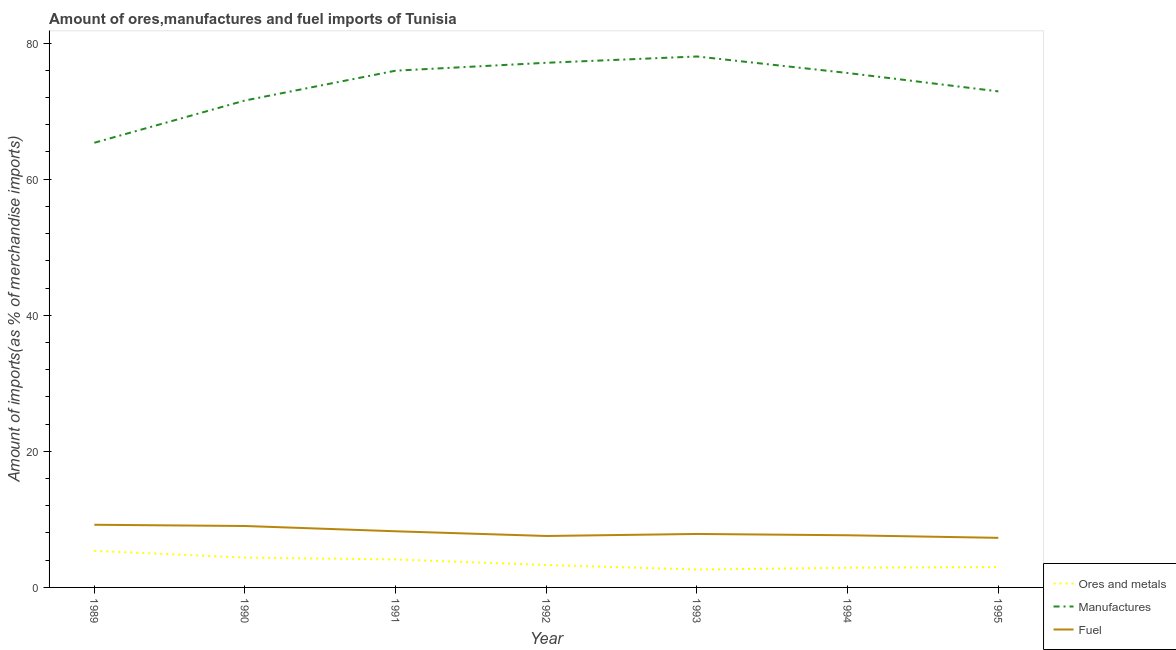How many different coloured lines are there?
Offer a very short reply. 3. Does the line corresponding to percentage of manufactures imports intersect with the line corresponding to percentage of ores and metals imports?
Your response must be concise. No. What is the percentage of ores and metals imports in 1995?
Your answer should be very brief. 2.99. Across all years, what is the maximum percentage of manufactures imports?
Give a very brief answer. 78.03. Across all years, what is the minimum percentage of ores and metals imports?
Keep it short and to the point. 2.63. What is the total percentage of ores and metals imports in the graph?
Offer a terse response. 25.68. What is the difference between the percentage of ores and metals imports in 1989 and that in 1992?
Keep it short and to the point. 2.09. What is the difference between the percentage of manufactures imports in 1995 and the percentage of ores and metals imports in 1991?
Keep it short and to the point. 68.79. What is the average percentage of manufactures imports per year?
Offer a terse response. 73.78. In the year 1989, what is the difference between the percentage of manufactures imports and percentage of ores and metals imports?
Make the answer very short. 59.97. In how many years, is the percentage of manufactures imports greater than 44 %?
Offer a terse response. 7. What is the ratio of the percentage of ores and metals imports in 1993 to that in 1994?
Provide a short and direct response. 0.91. Is the difference between the percentage of fuel imports in 1992 and 1994 greater than the difference between the percentage of ores and metals imports in 1992 and 1994?
Provide a succinct answer. No. What is the difference between the highest and the second highest percentage of manufactures imports?
Your answer should be compact. 0.93. What is the difference between the highest and the lowest percentage of manufactures imports?
Offer a terse response. 12.68. In how many years, is the percentage of fuel imports greater than the average percentage of fuel imports taken over all years?
Ensure brevity in your answer.  3. How many lines are there?
Give a very brief answer. 3. What is the difference between two consecutive major ticks on the Y-axis?
Your response must be concise. 20. Where does the legend appear in the graph?
Keep it short and to the point. Bottom right. How many legend labels are there?
Give a very brief answer. 3. How are the legend labels stacked?
Provide a succinct answer. Vertical. What is the title of the graph?
Provide a succinct answer. Amount of ores,manufactures and fuel imports of Tunisia. Does "Refusal of sex" appear as one of the legend labels in the graph?
Your response must be concise. No. What is the label or title of the X-axis?
Ensure brevity in your answer.  Year. What is the label or title of the Y-axis?
Your response must be concise. Amount of imports(as % of merchandise imports). What is the Amount of imports(as % of merchandise imports) in Ores and metals in 1989?
Offer a very short reply. 5.38. What is the Amount of imports(as % of merchandise imports) in Manufactures in 1989?
Give a very brief answer. 65.35. What is the Amount of imports(as % of merchandise imports) in Fuel in 1989?
Make the answer very short. 9.21. What is the Amount of imports(as % of merchandise imports) in Ores and metals in 1990?
Offer a terse response. 4.38. What is the Amount of imports(as % of merchandise imports) of Manufactures in 1990?
Make the answer very short. 71.56. What is the Amount of imports(as % of merchandise imports) of Fuel in 1990?
Provide a succinct answer. 9.03. What is the Amount of imports(as % of merchandise imports) in Ores and metals in 1991?
Give a very brief answer. 4.11. What is the Amount of imports(as % of merchandise imports) in Manufactures in 1991?
Your answer should be compact. 75.94. What is the Amount of imports(as % of merchandise imports) of Fuel in 1991?
Your answer should be compact. 8.25. What is the Amount of imports(as % of merchandise imports) in Ores and metals in 1992?
Offer a very short reply. 3.3. What is the Amount of imports(as % of merchandise imports) in Manufactures in 1992?
Your answer should be compact. 77.1. What is the Amount of imports(as % of merchandise imports) in Fuel in 1992?
Provide a short and direct response. 7.56. What is the Amount of imports(as % of merchandise imports) in Ores and metals in 1993?
Offer a terse response. 2.63. What is the Amount of imports(as % of merchandise imports) of Manufactures in 1993?
Give a very brief answer. 78.03. What is the Amount of imports(as % of merchandise imports) of Fuel in 1993?
Provide a succinct answer. 7.86. What is the Amount of imports(as % of merchandise imports) in Ores and metals in 1994?
Offer a very short reply. 2.89. What is the Amount of imports(as % of merchandise imports) of Manufactures in 1994?
Provide a succinct answer. 75.6. What is the Amount of imports(as % of merchandise imports) of Fuel in 1994?
Your answer should be very brief. 7.67. What is the Amount of imports(as % of merchandise imports) in Ores and metals in 1995?
Your response must be concise. 2.99. What is the Amount of imports(as % of merchandise imports) of Manufactures in 1995?
Your answer should be compact. 72.9. What is the Amount of imports(as % of merchandise imports) in Fuel in 1995?
Provide a succinct answer. 7.29. Across all years, what is the maximum Amount of imports(as % of merchandise imports) in Ores and metals?
Give a very brief answer. 5.38. Across all years, what is the maximum Amount of imports(as % of merchandise imports) in Manufactures?
Make the answer very short. 78.03. Across all years, what is the maximum Amount of imports(as % of merchandise imports) of Fuel?
Ensure brevity in your answer.  9.21. Across all years, what is the minimum Amount of imports(as % of merchandise imports) of Ores and metals?
Provide a succinct answer. 2.63. Across all years, what is the minimum Amount of imports(as % of merchandise imports) of Manufactures?
Your answer should be compact. 65.35. Across all years, what is the minimum Amount of imports(as % of merchandise imports) of Fuel?
Offer a very short reply. 7.29. What is the total Amount of imports(as % of merchandise imports) in Ores and metals in the graph?
Ensure brevity in your answer.  25.68. What is the total Amount of imports(as % of merchandise imports) of Manufactures in the graph?
Give a very brief answer. 516.47. What is the total Amount of imports(as % of merchandise imports) of Fuel in the graph?
Give a very brief answer. 56.86. What is the difference between the Amount of imports(as % of merchandise imports) of Manufactures in 1989 and that in 1990?
Your answer should be compact. -6.21. What is the difference between the Amount of imports(as % of merchandise imports) in Fuel in 1989 and that in 1990?
Offer a terse response. 0.18. What is the difference between the Amount of imports(as % of merchandise imports) in Ores and metals in 1989 and that in 1991?
Ensure brevity in your answer.  1.27. What is the difference between the Amount of imports(as % of merchandise imports) in Manufactures in 1989 and that in 1991?
Keep it short and to the point. -10.59. What is the difference between the Amount of imports(as % of merchandise imports) in Fuel in 1989 and that in 1991?
Provide a succinct answer. 0.96. What is the difference between the Amount of imports(as % of merchandise imports) in Ores and metals in 1989 and that in 1992?
Your answer should be very brief. 2.09. What is the difference between the Amount of imports(as % of merchandise imports) in Manufactures in 1989 and that in 1992?
Offer a terse response. -11.75. What is the difference between the Amount of imports(as % of merchandise imports) in Fuel in 1989 and that in 1992?
Make the answer very short. 1.65. What is the difference between the Amount of imports(as % of merchandise imports) of Ores and metals in 1989 and that in 1993?
Your answer should be very brief. 2.75. What is the difference between the Amount of imports(as % of merchandise imports) of Manufactures in 1989 and that in 1993?
Ensure brevity in your answer.  -12.68. What is the difference between the Amount of imports(as % of merchandise imports) in Fuel in 1989 and that in 1993?
Your answer should be compact. 1.35. What is the difference between the Amount of imports(as % of merchandise imports) in Ores and metals in 1989 and that in 1994?
Ensure brevity in your answer.  2.49. What is the difference between the Amount of imports(as % of merchandise imports) in Manufactures in 1989 and that in 1994?
Give a very brief answer. -10.25. What is the difference between the Amount of imports(as % of merchandise imports) of Fuel in 1989 and that in 1994?
Your response must be concise. 1.54. What is the difference between the Amount of imports(as % of merchandise imports) of Ores and metals in 1989 and that in 1995?
Your answer should be compact. 2.39. What is the difference between the Amount of imports(as % of merchandise imports) of Manufactures in 1989 and that in 1995?
Keep it short and to the point. -7.55. What is the difference between the Amount of imports(as % of merchandise imports) of Fuel in 1989 and that in 1995?
Your response must be concise. 1.92. What is the difference between the Amount of imports(as % of merchandise imports) in Ores and metals in 1990 and that in 1991?
Offer a terse response. 0.27. What is the difference between the Amount of imports(as % of merchandise imports) in Manufactures in 1990 and that in 1991?
Provide a short and direct response. -4.38. What is the difference between the Amount of imports(as % of merchandise imports) in Fuel in 1990 and that in 1991?
Your response must be concise. 0.78. What is the difference between the Amount of imports(as % of merchandise imports) of Ores and metals in 1990 and that in 1992?
Your answer should be compact. 1.09. What is the difference between the Amount of imports(as % of merchandise imports) in Manufactures in 1990 and that in 1992?
Ensure brevity in your answer.  -5.54. What is the difference between the Amount of imports(as % of merchandise imports) in Fuel in 1990 and that in 1992?
Ensure brevity in your answer.  1.47. What is the difference between the Amount of imports(as % of merchandise imports) of Ores and metals in 1990 and that in 1993?
Your answer should be very brief. 1.75. What is the difference between the Amount of imports(as % of merchandise imports) of Manufactures in 1990 and that in 1993?
Your response must be concise. -6.47. What is the difference between the Amount of imports(as % of merchandise imports) in Fuel in 1990 and that in 1993?
Offer a terse response. 1.17. What is the difference between the Amount of imports(as % of merchandise imports) of Ores and metals in 1990 and that in 1994?
Your answer should be very brief. 1.49. What is the difference between the Amount of imports(as % of merchandise imports) of Manufactures in 1990 and that in 1994?
Give a very brief answer. -4.04. What is the difference between the Amount of imports(as % of merchandise imports) in Fuel in 1990 and that in 1994?
Make the answer very short. 1.36. What is the difference between the Amount of imports(as % of merchandise imports) of Ores and metals in 1990 and that in 1995?
Make the answer very short. 1.39. What is the difference between the Amount of imports(as % of merchandise imports) of Manufactures in 1990 and that in 1995?
Your response must be concise. -1.34. What is the difference between the Amount of imports(as % of merchandise imports) in Fuel in 1990 and that in 1995?
Keep it short and to the point. 1.74. What is the difference between the Amount of imports(as % of merchandise imports) of Ores and metals in 1991 and that in 1992?
Provide a short and direct response. 0.82. What is the difference between the Amount of imports(as % of merchandise imports) of Manufactures in 1991 and that in 1992?
Provide a short and direct response. -1.16. What is the difference between the Amount of imports(as % of merchandise imports) of Fuel in 1991 and that in 1992?
Offer a terse response. 0.69. What is the difference between the Amount of imports(as % of merchandise imports) of Ores and metals in 1991 and that in 1993?
Make the answer very short. 1.48. What is the difference between the Amount of imports(as % of merchandise imports) of Manufactures in 1991 and that in 1993?
Ensure brevity in your answer.  -2.09. What is the difference between the Amount of imports(as % of merchandise imports) in Fuel in 1991 and that in 1993?
Your answer should be very brief. 0.39. What is the difference between the Amount of imports(as % of merchandise imports) in Ores and metals in 1991 and that in 1994?
Provide a succinct answer. 1.22. What is the difference between the Amount of imports(as % of merchandise imports) in Manufactures in 1991 and that in 1994?
Your answer should be compact. 0.34. What is the difference between the Amount of imports(as % of merchandise imports) of Fuel in 1991 and that in 1994?
Make the answer very short. 0.58. What is the difference between the Amount of imports(as % of merchandise imports) of Ores and metals in 1991 and that in 1995?
Make the answer very short. 1.12. What is the difference between the Amount of imports(as % of merchandise imports) of Manufactures in 1991 and that in 1995?
Give a very brief answer. 3.04. What is the difference between the Amount of imports(as % of merchandise imports) in Fuel in 1991 and that in 1995?
Ensure brevity in your answer.  0.96. What is the difference between the Amount of imports(as % of merchandise imports) in Ores and metals in 1992 and that in 1993?
Your response must be concise. 0.66. What is the difference between the Amount of imports(as % of merchandise imports) of Manufactures in 1992 and that in 1993?
Keep it short and to the point. -0.93. What is the difference between the Amount of imports(as % of merchandise imports) of Fuel in 1992 and that in 1993?
Ensure brevity in your answer.  -0.3. What is the difference between the Amount of imports(as % of merchandise imports) in Ores and metals in 1992 and that in 1994?
Ensure brevity in your answer.  0.41. What is the difference between the Amount of imports(as % of merchandise imports) of Manufactures in 1992 and that in 1994?
Offer a very short reply. 1.5. What is the difference between the Amount of imports(as % of merchandise imports) in Fuel in 1992 and that in 1994?
Make the answer very short. -0.11. What is the difference between the Amount of imports(as % of merchandise imports) in Ores and metals in 1992 and that in 1995?
Ensure brevity in your answer.  0.3. What is the difference between the Amount of imports(as % of merchandise imports) in Manufactures in 1992 and that in 1995?
Give a very brief answer. 4.2. What is the difference between the Amount of imports(as % of merchandise imports) of Fuel in 1992 and that in 1995?
Offer a terse response. 0.27. What is the difference between the Amount of imports(as % of merchandise imports) in Ores and metals in 1993 and that in 1994?
Your answer should be very brief. -0.26. What is the difference between the Amount of imports(as % of merchandise imports) of Manufactures in 1993 and that in 1994?
Provide a succinct answer. 2.43. What is the difference between the Amount of imports(as % of merchandise imports) in Fuel in 1993 and that in 1994?
Ensure brevity in your answer.  0.19. What is the difference between the Amount of imports(as % of merchandise imports) of Ores and metals in 1993 and that in 1995?
Your answer should be very brief. -0.36. What is the difference between the Amount of imports(as % of merchandise imports) in Manufactures in 1993 and that in 1995?
Keep it short and to the point. 5.13. What is the difference between the Amount of imports(as % of merchandise imports) of Fuel in 1993 and that in 1995?
Offer a very short reply. 0.57. What is the difference between the Amount of imports(as % of merchandise imports) in Ores and metals in 1994 and that in 1995?
Make the answer very short. -0.11. What is the difference between the Amount of imports(as % of merchandise imports) in Manufactures in 1994 and that in 1995?
Give a very brief answer. 2.7. What is the difference between the Amount of imports(as % of merchandise imports) in Fuel in 1994 and that in 1995?
Make the answer very short. 0.38. What is the difference between the Amount of imports(as % of merchandise imports) of Ores and metals in 1989 and the Amount of imports(as % of merchandise imports) of Manufactures in 1990?
Offer a very short reply. -66.18. What is the difference between the Amount of imports(as % of merchandise imports) in Ores and metals in 1989 and the Amount of imports(as % of merchandise imports) in Fuel in 1990?
Provide a succinct answer. -3.65. What is the difference between the Amount of imports(as % of merchandise imports) of Manufactures in 1989 and the Amount of imports(as % of merchandise imports) of Fuel in 1990?
Your response must be concise. 56.32. What is the difference between the Amount of imports(as % of merchandise imports) of Ores and metals in 1989 and the Amount of imports(as % of merchandise imports) of Manufactures in 1991?
Make the answer very short. -70.56. What is the difference between the Amount of imports(as % of merchandise imports) in Ores and metals in 1989 and the Amount of imports(as % of merchandise imports) in Fuel in 1991?
Your response must be concise. -2.87. What is the difference between the Amount of imports(as % of merchandise imports) of Manufactures in 1989 and the Amount of imports(as % of merchandise imports) of Fuel in 1991?
Offer a very short reply. 57.1. What is the difference between the Amount of imports(as % of merchandise imports) of Ores and metals in 1989 and the Amount of imports(as % of merchandise imports) of Manufactures in 1992?
Offer a very short reply. -71.72. What is the difference between the Amount of imports(as % of merchandise imports) of Ores and metals in 1989 and the Amount of imports(as % of merchandise imports) of Fuel in 1992?
Ensure brevity in your answer.  -2.18. What is the difference between the Amount of imports(as % of merchandise imports) of Manufactures in 1989 and the Amount of imports(as % of merchandise imports) of Fuel in 1992?
Make the answer very short. 57.79. What is the difference between the Amount of imports(as % of merchandise imports) in Ores and metals in 1989 and the Amount of imports(as % of merchandise imports) in Manufactures in 1993?
Offer a very short reply. -72.65. What is the difference between the Amount of imports(as % of merchandise imports) in Ores and metals in 1989 and the Amount of imports(as % of merchandise imports) in Fuel in 1993?
Provide a short and direct response. -2.48. What is the difference between the Amount of imports(as % of merchandise imports) in Manufactures in 1989 and the Amount of imports(as % of merchandise imports) in Fuel in 1993?
Your answer should be compact. 57.49. What is the difference between the Amount of imports(as % of merchandise imports) in Ores and metals in 1989 and the Amount of imports(as % of merchandise imports) in Manufactures in 1994?
Provide a short and direct response. -70.22. What is the difference between the Amount of imports(as % of merchandise imports) of Ores and metals in 1989 and the Amount of imports(as % of merchandise imports) of Fuel in 1994?
Your response must be concise. -2.29. What is the difference between the Amount of imports(as % of merchandise imports) in Manufactures in 1989 and the Amount of imports(as % of merchandise imports) in Fuel in 1994?
Offer a very short reply. 57.68. What is the difference between the Amount of imports(as % of merchandise imports) of Ores and metals in 1989 and the Amount of imports(as % of merchandise imports) of Manufactures in 1995?
Offer a very short reply. -67.52. What is the difference between the Amount of imports(as % of merchandise imports) of Ores and metals in 1989 and the Amount of imports(as % of merchandise imports) of Fuel in 1995?
Provide a short and direct response. -1.91. What is the difference between the Amount of imports(as % of merchandise imports) of Manufactures in 1989 and the Amount of imports(as % of merchandise imports) of Fuel in 1995?
Your response must be concise. 58.06. What is the difference between the Amount of imports(as % of merchandise imports) in Ores and metals in 1990 and the Amount of imports(as % of merchandise imports) in Manufactures in 1991?
Your response must be concise. -71.56. What is the difference between the Amount of imports(as % of merchandise imports) of Ores and metals in 1990 and the Amount of imports(as % of merchandise imports) of Fuel in 1991?
Give a very brief answer. -3.87. What is the difference between the Amount of imports(as % of merchandise imports) of Manufactures in 1990 and the Amount of imports(as % of merchandise imports) of Fuel in 1991?
Your answer should be compact. 63.31. What is the difference between the Amount of imports(as % of merchandise imports) in Ores and metals in 1990 and the Amount of imports(as % of merchandise imports) in Manufactures in 1992?
Make the answer very short. -72.72. What is the difference between the Amount of imports(as % of merchandise imports) of Ores and metals in 1990 and the Amount of imports(as % of merchandise imports) of Fuel in 1992?
Ensure brevity in your answer.  -3.18. What is the difference between the Amount of imports(as % of merchandise imports) in Manufactures in 1990 and the Amount of imports(as % of merchandise imports) in Fuel in 1992?
Your answer should be very brief. 64. What is the difference between the Amount of imports(as % of merchandise imports) of Ores and metals in 1990 and the Amount of imports(as % of merchandise imports) of Manufactures in 1993?
Keep it short and to the point. -73.65. What is the difference between the Amount of imports(as % of merchandise imports) in Ores and metals in 1990 and the Amount of imports(as % of merchandise imports) in Fuel in 1993?
Keep it short and to the point. -3.48. What is the difference between the Amount of imports(as % of merchandise imports) of Manufactures in 1990 and the Amount of imports(as % of merchandise imports) of Fuel in 1993?
Ensure brevity in your answer.  63.7. What is the difference between the Amount of imports(as % of merchandise imports) of Ores and metals in 1990 and the Amount of imports(as % of merchandise imports) of Manufactures in 1994?
Provide a short and direct response. -71.22. What is the difference between the Amount of imports(as % of merchandise imports) in Ores and metals in 1990 and the Amount of imports(as % of merchandise imports) in Fuel in 1994?
Make the answer very short. -3.29. What is the difference between the Amount of imports(as % of merchandise imports) in Manufactures in 1990 and the Amount of imports(as % of merchandise imports) in Fuel in 1994?
Make the answer very short. 63.89. What is the difference between the Amount of imports(as % of merchandise imports) in Ores and metals in 1990 and the Amount of imports(as % of merchandise imports) in Manufactures in 1995?
Give a very brief answer. -68.52. What is the difference between the Amount of imports(as % of merchandise imports) in Ores and metals in 1990 and the Amount of imports(as % of merchandise imports) in Fuel in 1995?
Your answer should be compact. -2.91. What is the difference between the Amount of imports(as % of merchandise imports) in Manufactures in 1990 and the Amount of imports(as % of merchandise imports) in Fuel in 1995?
Keep it short and to the point. 64.27. What is the difference between the Amount of imports(as % of merchandise imports) in Ores and metals in 1991 and the Amount of imports(as % of merchandise imports) in Manufactures in 1992?
Ensure brevity in your answer.  -72.99. What is the difference between the Amount of imports(as % of merchandise imports) in Ores and metals in 1991 and the Amount of imports(as % of merchandise imports) in Fuel in 1992?
Your answer should be compact. -3.45. What is the difference between the Amount of imports(as % of merchandise imports) of Manufactures in 1991 and the Amount of imports(as % of merchandise imports) of Fuel in 1992?
Offer a very short reply. 68.38. What is the difference between the Amount of imports(as % of merchandise imports) of Ores and metals in 1991 and the Amount of imports(as % of merchandise imports) of Manufactures in 1993?
Give a very brief answer. -73.91. What is the difference between the Amount of imports(as % of merchandise imports) in Ores and metals in 1991 and the Amount of imports(as % of merchandise imports) in Fuel in 1993?
Make the answer very short. -3.74. What is the difference between the Amount of imports(as % of merchandise imports) in Manufactures in 1991 and the Amount of imports(as % of merchandise imports) in Fuel in 1993?
Offer a terse response. 68.08. What is the difference between the Amount of imports(as % of merchandise imports) of Ores and metals in 1991 and the Amount of imports(as % of merchandise imports) of Manufactures in 1994?
Keep it short and to the point. -71.49. What is the difference between the Amount of imports(as % of merchandise imports) in Ores and metals in 1991 and the Amount of imports(as % of merchandise imports) in Fuel in 1994?
Give a very brief answer. -3.55. What is the difference between the Amount of imports(as % of merchandise imports) in Manufactures in 1991 and the Amount of imports(as % of merchandise imports) in Fuel in 1994?
Your answer should be very brief. 68.27. What is the difference between the Amount of imports(as % of merchandise imports) of Ores and metals in 1991 and the Amount of imports(as % of merchandise imports) of Manufactures in 1995?
Ensure brevity in your answer.  -68.79. What is the difference between the Amount of imports(as % of merchandise imports) of Ores and metals in 1991 and the Amount of imports(as % of merchandise imports) of Fuel in 1995?
Your response must be concise. -3.17. What is the difference between the Amount of imports(as % of merchandise imports) in Manufactures in 1991 and the Amount of imports(as % of merchandise imports) in Fuel in 1995?
Offer a terse response. 68.65. What is the difference between the Amount of imports(as % of merchandise imports) in Ores and metals in 1992 and the Amount of imports(as % of merchandise imports) in Manufactures in 1993?
Make the answer very short. -74.73. What is the difference between the Amount of imports(as % of merchandise imports) in Ores and metals in 1992 and the Amount of imports(as % of merchandise imports) in Fuel in 1993?
Provide a succinct answer. -4.56. What is the difference between the Amount of imports(as % of merchandise imports) in Manufactures in 1992 and the Amount of imports(as % of merchandise imports) in Fuel in 1993?
Offer a terse response. 69.24. What is the difference between the Amount of imports(as % of merchandise imports) in Ores and metals in 1992 and the Amount of imports(as % of merchandise imports) in Manufactures in 1994?
Offer a terse response. -72.3. What is the difference between the Amount of imports(as % of merchandise imports) in Ores and metals in 1992 and the Amount of imports(as % of merchandise imports) in Fuel in 1994?
Your answer should be compact. -4.37. What is the difference between the Amount of imports(as % of merchandise imports) of Manufactures in 1992 and the Amount of imports(as % of merchandise imports) of Fuel in 1994?
Give a very brief answer. 69.43. What is the difference between the Amount of imports(as % of merchandise imports) of Ores and metals in 1992 and the Amount of imports(as % of merchandise imports) of Manufactures in 1995?
Offer a very short reply. -69.6. What is the difference between the Amount of imports(as % of merchandise imports) in Ores and metals in 1992 and the Amount of imports(as % of merchandise imports) in Fuel in 1995?
Your answer should be very brief. -3.99. What is the difference between the Amount of imports(as % of merchandise imports) of Manufactures in 1992 and the Amount of imports(as % of merchandise imports) of Fuel in 1995?
Provide a succinct answer. 69.81. What is the difference between the Amount of imports(as % of merchandise imports) in Ores and metals in 1993 and the Amount of imports(as % of merchandise imports) in Manufactures in 1994?
Provide a succinct answer. -72.97. What is the difference between the Amount of imports(as % of merchandise imports) in Ores and metals in 1993 and the Amount of imports(as % of merchandise imports) in Fuel in 1994?
Offer a terse response. -5.04. What is the difference between the Amount of imports(as % of merchandise imports) in Manufactures in 1993 and the Amount of imports(as % of merchandise imports) in Fuel in 1994?
Your answer should be compact. 70.36. What is the difference between the Amount of imports(as % of merchandise imports) of Ores and metals in 1993 and the Amount of imports(as % of merchandise imports) of Manufactures in 1995?
Your answer should be compact. -70.27. What is the difference between the Amount of imports(as % of merchandise imports) in Ores and metals in 1993 and the Amount of imports(as % of merchandise imports) in Fuel in 1995?
Offer a very short reply. -4.66. What is the difference between the Amount of imports(as % of merchandise imports) in Manufactures in 1993 and the Amount of imports(as % of merchandise imports) in Fuel in 1995?
Offer a very short reply. 70.74. What is the difference between the Amount of imports(as % of merchandise imports) of Ores and metals in 1994 and the Amount of imports(as % of merchandise imports) of Manufactures in 1995?
Keep it short and to the point. -70.01. What is the difference between the Amount of imports(as % of merchandise imports) of Ores and metals in 1994 and the Amount of imports(as % of merchandise imports) of Fuel in 1995?
Give a very brief answer. -4.4. What is the difference between the Amount of imports(as % of merchandise imports) in Manufactures in 1994 and the Amount of imports(as % of merchandise imports) in Fuel in 1995?
Make the answer very short. 68.31. What is the average Amount of imports(as % of merchandise imports) in Ores and metals per year?
Offer a very short reply. 3.67. What is the average Amount of imports(as % of merchandise imports) in Manufactures per year?
Make the answer very short. 73.78. What is the average Amount of imports(as % of merchandise imports) of Fuel per year?
Your response must be concise. 8.12. In the year 1989, what is the difference between the Amount of imports(as % of merchandise imports) in Ores and metals and Amount of imports(as % of merchandise imports) in Manufactures?
Make the answer very short. -59.97. In the year 1989, what is the difference between the Amount of imports(as % of merchandise imports) of Ores and metals and Amount of imports(as % of merchandise imports) of Fuel?
Keep it short and to the point. -3.83. In the year 1989, what is the difference between the Amount of imports(as % of merchandise imports) of Manufactures and Amount of imports(as % of merchandise imports) of Fuel?
Your response must be concise. 56.14. In the year 1990, what is the difference between the Amount of imports(as % of merchandise imports) in Ores and metals and Amount of imports(as % of merchandise imports) in Manufactures?
Your answer should be very brief. -67.18. In the year 1990, what is the difference between the Amount of imports(as % of merchandise imports) of Ores and metals and Amount of imports(as % of merchandise imports) of Fuel?
Give a very brief answer. -4.65. In the year 1990, what is the difference between the Amount of imports(as % of merchandise imports) in Manufactures and Amount of imports(as % of merchandise imports) in Fuel?
Your answer should be compact. 62.53. In the year 1991, what is the difference between the Amount of imports(as % of merchandise imports) in Ores and metals and Amount of imports(as % of merchandise imports) in Manufactures?
Provide a short and direct response. -71.83. In the year 1991, what is the difference between the Amount of imports(as % of merchandise imports) in Ores and metals and Amount of imports(as % of merchandise imports) in Fuel?
Provide a short and direct response. -4.14. In the year 1991, what is the difference between the Amount of imports(as % of merchandise imports) in Manufactures and Amount of imports(as % of merchandise imports) in Fuel?
Ensure brevity in your answer.  67.69. In the year 1992, what is the difference between the Amount of imports(as % of merchandise imports) in Ores and metals and Amount of imports(as % of merchandise imports) in Manufactures?
Keep it short and to the point. -73.8. In the year 1992, what is the difference between the Amount of imports(as % of merchandise imports) of Ores and metals and Amount of imports(as % of merchandise imports) of Fuel?
Make the answer very short. -4.26. In the year 1992, what is the difference between the Amount of imports(as % of merchandise imports) in Manufactures and Amount of imports(as % of merchandise imports) in Fuel?
Offer a very short reply. 69.54. In the year 1993, what is the difference between the Amount of imports(as % of merchandise imports) of Ores and metals and Amount of imports(as % of merchandise imports) of Manufactures?
Make the answer very short. -75.4. In the year 1993, what is the difference between the Amount of imports(as % of merchandise imports) of Ores and metals and Amount of imports(as % of merchandise imports) of Fuel?
Offer a very short reply. -5.23. In the year 1993, what is the difference between the Amount of imports(as % of merchandise imports) of Manufactures and Amount of imports(as % of merchandise imports) of Fuel?
Offer a terse response. 70.17. In the year 1994, what is the difference between the Amount of imports(as % of merchandise imports) in Ores and metals and Amount of imports(as % of merchandise imports) in Manufactures?
Offer a very short reply. -72.71. In the year 1994, what is the difference between the Amount of imports(as % of merchandise imports) in Ores and metals and Amount of imports(as % of merchandise imports) in Fuel?
Make the answer very short. -4.78. In the year 1994, what is the difference between the Amount of imports(as % of merchandise imports) in Manufactures and Amount of imports(as % of merchandise imports) in Fuel?
Offer a terse response. 67.93. In the year 1995, what is the difference between the Amount of imports(as % of merchandise imports) in Ores and metals and Amount of imports(as % of merchandise imports) in Manufactures?
Give a very brief answer. -69.91. In the year 1995, what is the difference between the Amount of imports(as % of merchandise imports) in Ores and metals and Amount of imports(as % of merchandise imports) in Fuel?
Your answer should be very brief. -4.29. In the year 1995, what is the difference between the Amount of imports(as % of merchandise imports) of Manufactures and Amount of imports(as % of merchandise imports) of Fuel?
Ensure brevity in your answer.  65.61. What is the ratio of the Amount of imports(as % of merchandise imports) of Ores and metals in 1989 to that in 1990?
Your answer should be compact. 1.23. What is the ratio of the Amount of imports(as % of merchandise imports) of Manufactures in 1989 to that in 1990?
Provide a short and direct response. 0.91. What is the ratio of the Amount of imports(as % of merchandise imports) in Fuel in 1989 to that in 1990?
Keep it short and to the point. 1.02. What is the ratio of the Amount of imports(as % of merchandise imports) in Ores and metals in 1989 to that in 1991?
Your response must be concise. 1.31. What is the ratio of the Amount of imports(as % of merchandise imports) of Manufactures in 1989 to that in 1991?
Your answer should be very brief. 0.86. What is the ratio of the Amount of imports(as % of merchandise imports) of Fuel in 1989 to that in 1991?
Provide a succinct answer. 1.12. What is the ratio of the Amount of imports(as % of merchandise imports) in Ores and metals in 1989 to that in 1992?
Offer a very short reply. 1.63. What is the ratio of the Amount of imports(as % of merchandise imports) in Manufactures in 1989 to that in 1992?
Your answer should be very brief. 0.85. What is the ratio of the Amount of imports(as % of merchandise imports) of Fuel in 1989 to that in 1992?
Provide a short and direct response. 1.22. What is the ratio of the Amount of imports(as % of merchandise imports) of Ores and metals in 1989 to that in 1993?
Give a very brief answer. 2.05. What is the ratio of the Amount of imports(as % of merchandise imports) of Manufactures in 1989 to that in 1993?
Keep it short and to the point. 0.84. What is the ratio of the Amount of imports(as % of merchandise imports) in Fuel in 1989 to that in 1993?
Offer a terse response. 1.17. What is the ratio of the Amount of imports(as % of merchandise imports) of Ores and metals in 1989 to that in 1994?
Your answer should be very brief. 1.86. What is the ratio of the Amount of imports(as % of merchandise imports) in Manufactures in 1989 to that in 1994?
Offer a very short reply. 0.86. What is the ratio of the Amount of imports(as % of merchandise imports) in Fuel in 1989 to that in 1994?
Your response must be concise. 1.2. What is the ratio of the Amount of imports(as % of merchandise imports) in Ores and metals in 1989 to that in 1995?
Your response must be concise. 1.8. What is the ratio of the Amount of imports(as % of merchandise imports) of Manufactures in 1989 to that in 1995?
Offer a very short reply. 0.9. What is the ratio of the Amount of imports(as % of merchandise imports) of Fuel in 1989 to that in 1995?
Make the answer very short. 1.26. What is the ratio of the Amount of imports(as % of merchandise imports) of Ores and metals in 1990 to that in 1991?
Provide a short and direct response. 1.07. What is the ratio of the Amount of imports(as % of merchandise imports) of Manufactures in 1990 to that in 1991?
Your answer should be very brief. 0.94. What is the ratio of the Amount of imports(as % of merchandise imports) in Fuel in 1990 to that in 1991?
Your answer should be compact. 1.09. What is the ratio of the Amount of imports(as % of merchandise imports) of Ores and metals in 1990 to that in 1992?
Offer a terse response. 1.33. What is the ratio of the Amount of imports(as % of merchandise imports) in Manufactures in 1990 to that in 1992?
Your answer should be compact. 0.93. What is the ratio of the Amount of imports(as % of merchandise imports) in Fuel in 1990 to that in 1992?
Your response must be concise. 1.19. What is the ratio of the Amount of imports(as % of merchandise imports) of Ores and metals in 1990 to that in 1993?
Ensure brevity in your answer.  1.67. What is the ratio of the Amount of imports(as % of merchandise imports) in Manufactures in 1990 to that in 1993?
Ensure brevity in your answer.  0.92. What is the ratio of the Amount of imports(as % of merchandise imports) in Fuel in 1990 to that in 1993?
Provide a short and direct response. 1.15. What is the ratio of the Amount of imports(as % of merchandise imports) of Ores and metals in 1990 to that in 1994?
Make the answer very short. 1.52. What is the ratio of the Amount of imports(as % of merchandise imports) in Manufactures in 1990 to that in 1994?
Your answer should be very brief. 0.95. What is the ratio of the Amount of imports(as % of merchandise imports) of Fuel in 1990 to that in 1994?
Provide a short and direct response. 1.18. What is the ratio of the Amount of imports(as % of merchandise imports) in Ores and metals in 1990 to that in 1995?
Offer a very short reply. 1.46. What is the ratio of the Amount of imports(as % of merchandise imports) of Manufactures in 1990 to that in 1995?
Keep it short and to the point. 0.98. What is the ratio of the Amount of imports(as % of merchandise imports) of Fuel in 1990 to that in 1995?
Keep it short and to the point. 1.24. What is the ratio of the Amount of imports(as % of merchandise imports) of Ores and metals in 1991 to that in 1992?
Keep it short and to the point. 1.25. What is the ratio of the Amount of imports(as % of merchandise imports) in Fuel in 1991 to that in 1992?
Offer a terse response. 1.09. What is the ratio of the Amount of imports(as % of merchandise imports) of Ores and metals in 1991 to that in 1993?
Keep it short and to the point. 1.56. What is the ratio of the Amount of imports(as % of merchandise imports) of Manufactures in 1991 to that in 1993?
Offer a very short reply. 0.97. What is the ratio of the Amount of imports(as % of merchandise imports) in Fuel in 1991 to that in 1993?
Offer a very short reply. 1.05. What is the ratio of the Amount of imports(as % of merchandise imports) in Ores and metals in 1991 to that in 1994?
Provide a succinct answer. 1.42. What is the ratio of the Amount of imports(as % of merchandise imports) of Manufactures in 1991 to that in 1994?
Provide a short and direct response. 1. What is the ratio of the Amount of imports(as % of merchandise imports) in Fuel in 1991 to that in 1994?
Provide a succinct answer. 1.08. What is the ratio of the Amount of imports(as % of merchandise imports) in Ores and metals in 1991 to that in 1995?
Your answer should be compact. 1.37. What is the ratio of the Amount of imports(as % of merchandise imports) in Manufactures in 1991 to that in 1995?
Make the answer very short. 1.04. What is the ratio of the Amount of imports(as % of merchandise imports) of Fuel in 1991 to that in 1995?
Provide a short and direct response. 1.13. What is the ratio of the Amount of imports(as % of merchandise imports) of Ores and metals in 1992 to that in 1993?
Your answer should be compact. 1.25. What is the ratio of the Amount of imports(as % of merchandise imports) in Manufactures in 1992 to that in 1993?
Make the answer very short. 0.99. What is the ratio of the Amount of imports(as % of merchandise imports) in Fuel in 1992 to that in 1993?
Your response must be concise. 0.96. What is the ratio of the Amount of imports(as % of merchandise imports) in Ores and metals in 1992 to that in 1994?
Give a very brief answer. 1.14. What is the ratio of the Amount of imports(as % of merchandise imports) of Manufactures in 1992 to that in 1994?
Provide a short and direct response. 1.02. What is the ratio of the Amount of imports(as % of merchandise imports) of Fuel in 1992 to that in 1994?
Offer a very short reply. 0.99. What is the ratio of the Amount of imports(as % of merchandise imports) in Ores and metals in 1992 to that in 1995?
Your answer should be very brief. 1.1. What is the ratio of the Amount of imports(as % of merchandise imports) in Manufactures in 1992 to that in 1995?
Provide a succinct answer. 1.06. What is the ratio of the Amount of imports(as % of merchandise imports) in Fuel in 1992 to that in 1995?
Provide a succinct answer. 1.04. What is the ratio of the Amount of imports(as % of merchandise imports) of Ores and metals in 1993 to that in 1994?
Keep it short and to the point. 0.91. What is the ratio of the Amount of imports(as % of merchandise imports) of Manufactures in 1993 to that in 1994?
Your answer should be compact. 1.03. What is the ratio of the Amount of imports(as % of merchandise imports) in Fuel in 1993 to that in 1994?
Give a very brief answer. 1.02. What is the ratio of the Amount of imports(as % of merchandise imports) in Ores and metals in 1993 to that in 1995?
Keep it short and to the point. 0.88. What is the ratio of the Amount of imports(as % of merchandise imports) in Manufactures in 1993 to that in 1995?
Give a very brief answer. 1.07. What is the ratio of the Amount of imports(as % of merchandise imports) in Fuel in 1993 to that in 1995?
Keep it short and to the point. 1.08. What is the ratio of the Amount of imports(as % of merchandise imports) in Ores and metals in 1994 to that in 1995?
Ensure brevity in your answer.  0.96. What is the ratio of the Amount of imports(as % of merchandise imports) in Fuel in 1994 to that in 1995?
Offer a very short reply. 1.05. What is the difference between the highest and the second highest Amount of imports(as % of merchandise imports) of Ores and metals?
Provide a succinct answer. 1. What is the difference between the highest and the second highest Amount of imports(as % of merchandise imports) of Manufactures?
Keep it short and to the point. 0.93. What is the difference between the highest and the second highest Amount of imports(as % of merchandise imports) of Fuel?
Give a very brief answer. 0.18. What is the difference between the highest and the lowest Amount of imports(as % of merchandise imports) in Ores and metals?
Offer a very short reply. 2.75. What is the difference between the highest and the lowest Amount of imports(as % of merchandise imports) in Manufactures?
Your response must be concise. 12.68. What is the difference between the highest and the lowest Amount of imports(as % of merchandise imports) of Fuel?
Your response must be concise. 1.92. 